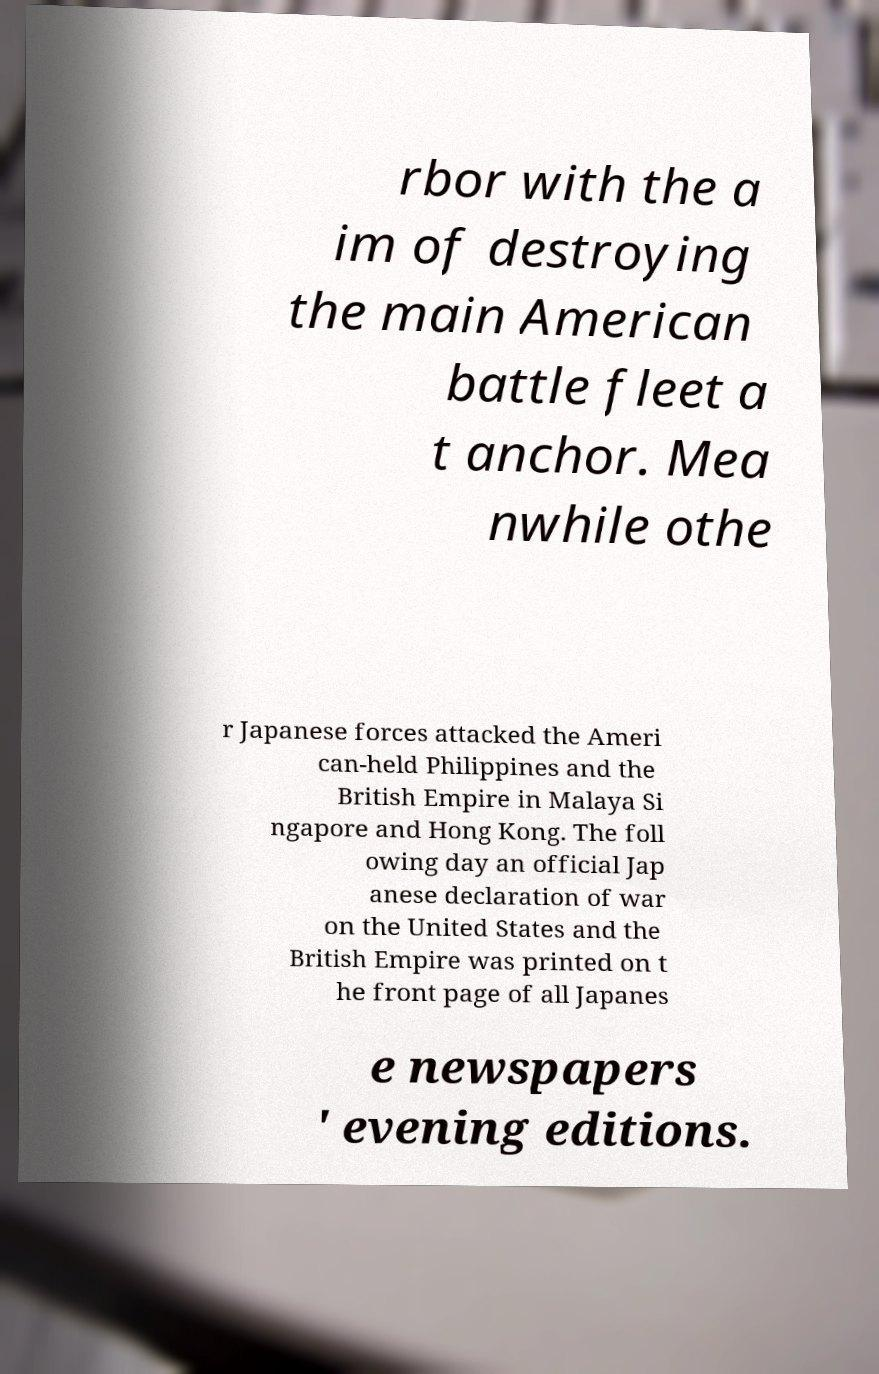Please read and relay the text visible in this image. What does it say? rbor with the a im of destroying the main American battle fleet a t anchor. Mea nwhile othe r Japanese forces attacked the Ameri can-held Philippines and the British Empire in Malaya Si ngapore and Hong Kong. The foll owing day an official Jap anese declaration of war on the United States and the British Empire was printed on t he front page of all Japanes e newspapers ' evening editions. 